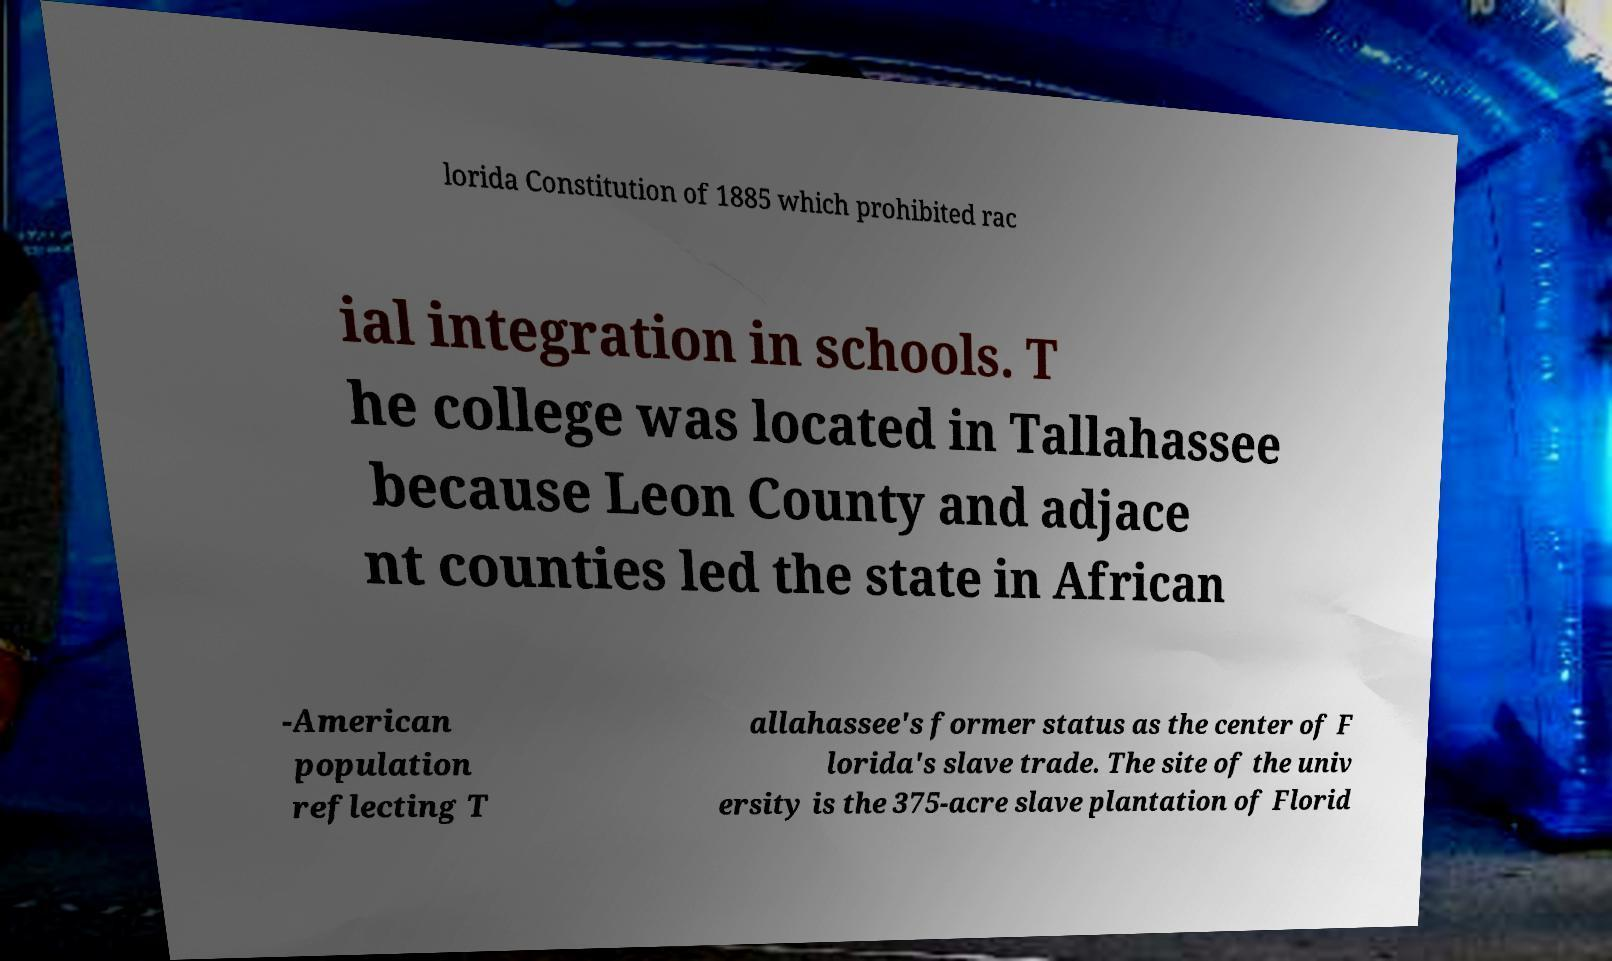What messages or text are displayed in this image? I need them in a readable, typed format. lorida Constitution of 1885 which prohibited rac ial integration in schools. T he college was located in Tallahassee because Leon County and adjace nt counties led the state in African -American population reflecting T allahassee's former status as the center of F lorida's slave trade. The site of the univ ersity is the 375-acre slave plantation of Florid 